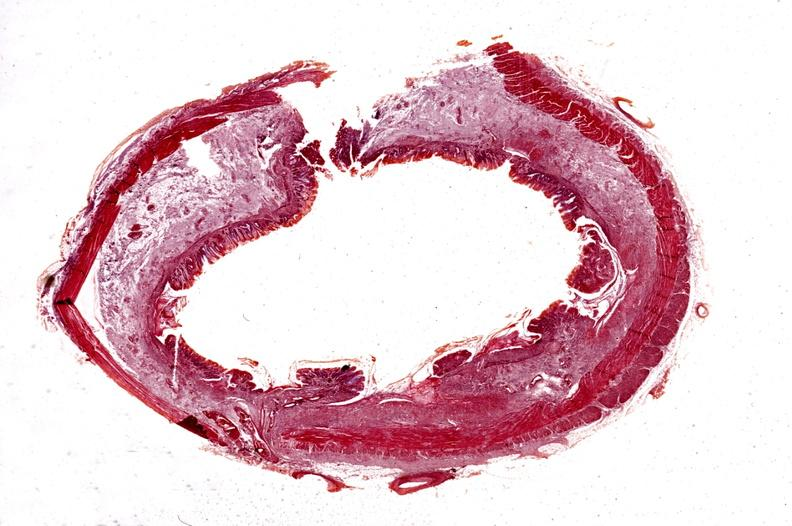where is this from?
Answer the question using a single word or phrase. Gastrointestinal system 